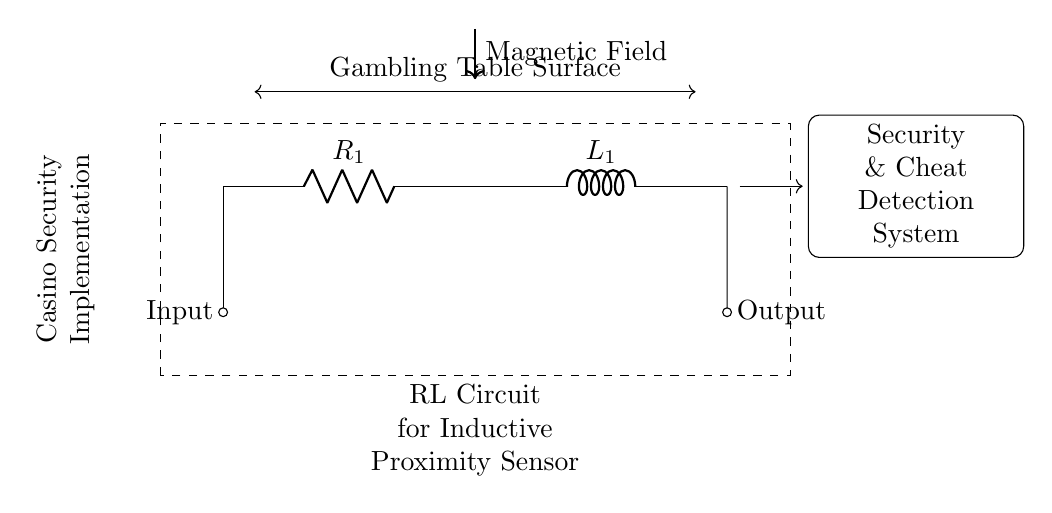What components are present in the circuit? The circuit contains a resistor labeled R1 and an inductor labeled L1, which are essential components in the RL circuit.
Answer: Resistor and Inductor What is the purpose of the dashed rectangle around the circuit? The dashed rectangle indicates the enclosed area for the RL circuit specifically designed for the inductive proximity sensor in this application.
Answer: Enclosed area for RL Circuit How does the magnetic field interact in this circuit? The arrow indicating the magnetic field shows that it influences the behavior of the circuit components, particularly the inductor, affecting the inductance and response of the sensor.
Answer: Influences RL Circuit What is being detected by the inductive proximity sensor? The inductive proximity sensor detects metal objects or changes in proximity due to the magnetic field generated in the circuit.
Answer: Metal objects Explain the significance of the "Security & Cheat Detection System" label. This label indicates the purpose of the whole circuit, which is designed not only for security features but also for detecting cheating behaviors at gambling tables by monitoring the inductance changes.
Answer: Security & Cheat Detection What occurs at the gambling table surface as shown in the diagram? The gambling table surface is where the sensor operates, detecting any metallic interference or presence, thus playing a crucial role in security.
Answer: Detection of interference How does the RL circuit contribute to the overall functionality of the sensor? The RL circuit provides the necessary electromagnetic characteristics to accurately detect changes caused by the proximity of metal objects, essential for security applications in gambling areas.
Answer: Electromagnetic detection 